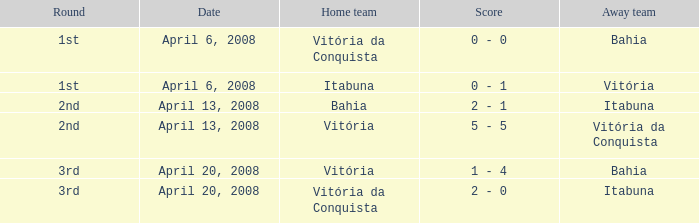What is the name of the home team on April 13, 2008 when Itabuna was the away team? Bahia. 